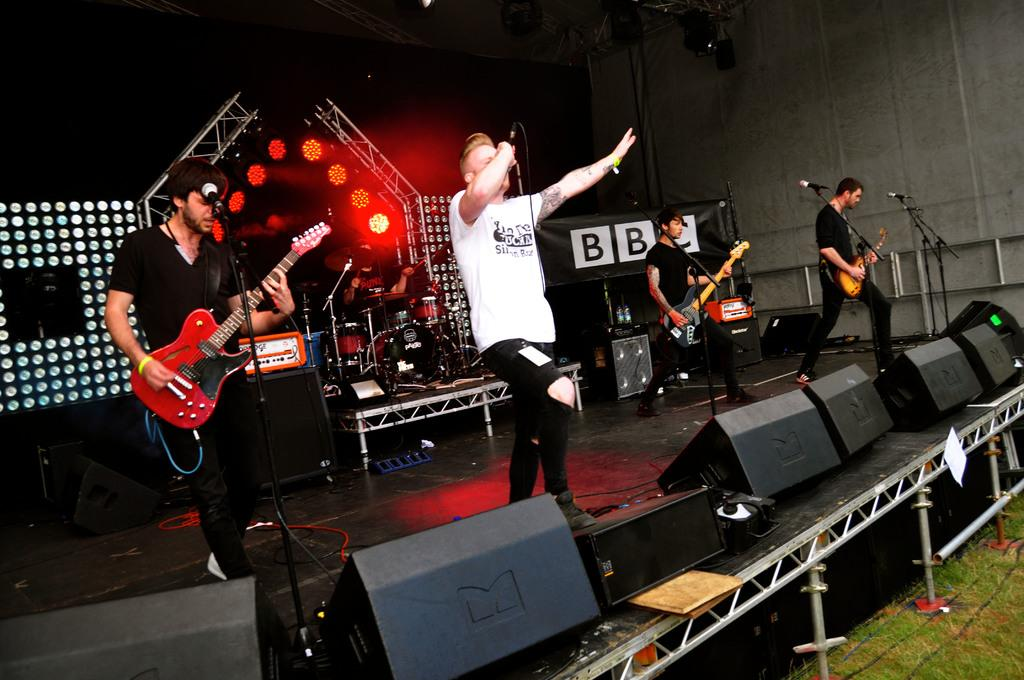What are the people in the image holding? The people in the image are holding guitars. Is there anyone else in the image besides the people holding guitars? Yes, there is a man holding a microphone in the image. Reasoning: Leting: Let's think step by step in order to produce the conversation. We start by identifying the main subjects in the image, which are the people holding guitars. Then, we expand the conversation to include the man holding a microphone, as mentioned in the second fact. Each question is designed to elicit a specific detail about the image that is known from the provided facts. Absurd Question/Answer: Can you see any toads playing in the ocean with oranges in the image? No, there are no toads, oceans, or oranges present in the image. 